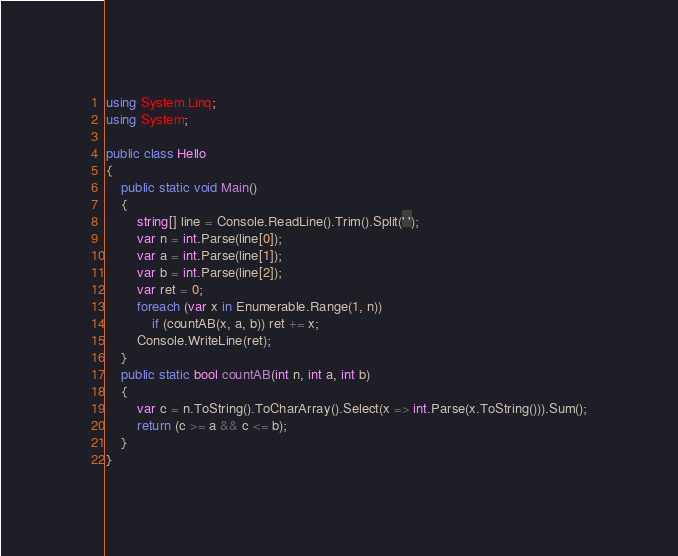<code> <loc_0><loc_0><loc_500><loc_500><_C#_>using System.Linq;
using System;

public class Hello
{
    public static void Main()
    {
        string[] line = Console.ReadLine().Trim().Split(' ');
        var n = int.Parse(line[0]);
        var a = int.Parse(line[1]);
        var b = int.Parse(line[2]);
        var ret = 0;
        foreach (var x in Enumerable.Range(1, n))
            if (countAB(x, a, b)) ret += x;
        Console.WriteLine(ret);
    }
    public static bool countAB(int n, int a, int b)
    {
        var c = n.ToString().ToCharArray().Select(x => int.Parse(x.ToString())).Sum();
        return (c >= a && c <= b);
    }
}</code> 